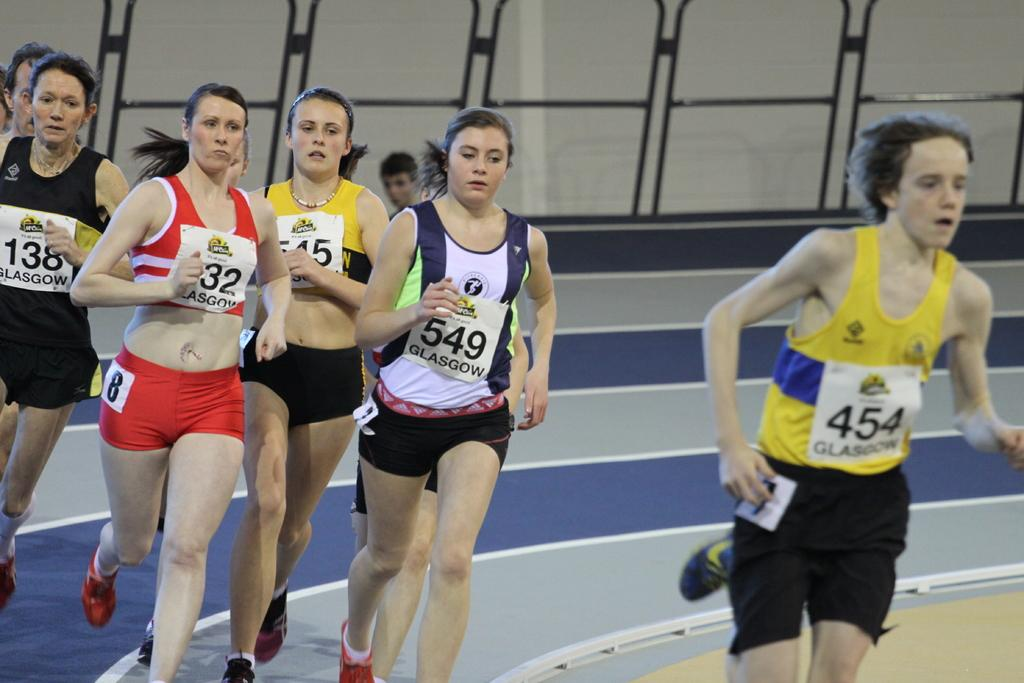Provide a one-sentence caption for the provided image. The track stars are being led by number 454 as they come around the bend. 